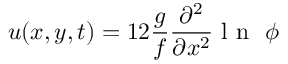<formula> <loc_0><loc_0><loc_500><loc_500>u ( x , y , t ) = 1 2 \frac { g } { f } \frac { \partial ^ { 2 } } { \partial x ^ { 2 } } l n \ \phi</formula> 